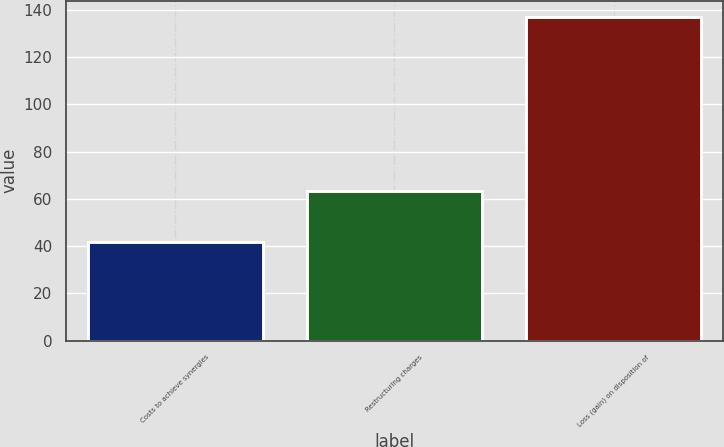Convert chart. <chart><loc_0><loc_0><loc_500><loc_500><bar_chart><fcel>Costs to achieve synergies<fcel>Restructuring charges<fcel>Loss (gain) on disposition of<nl><fcel>41.8<fcel>63.2<fcel>137<nl></chart> 